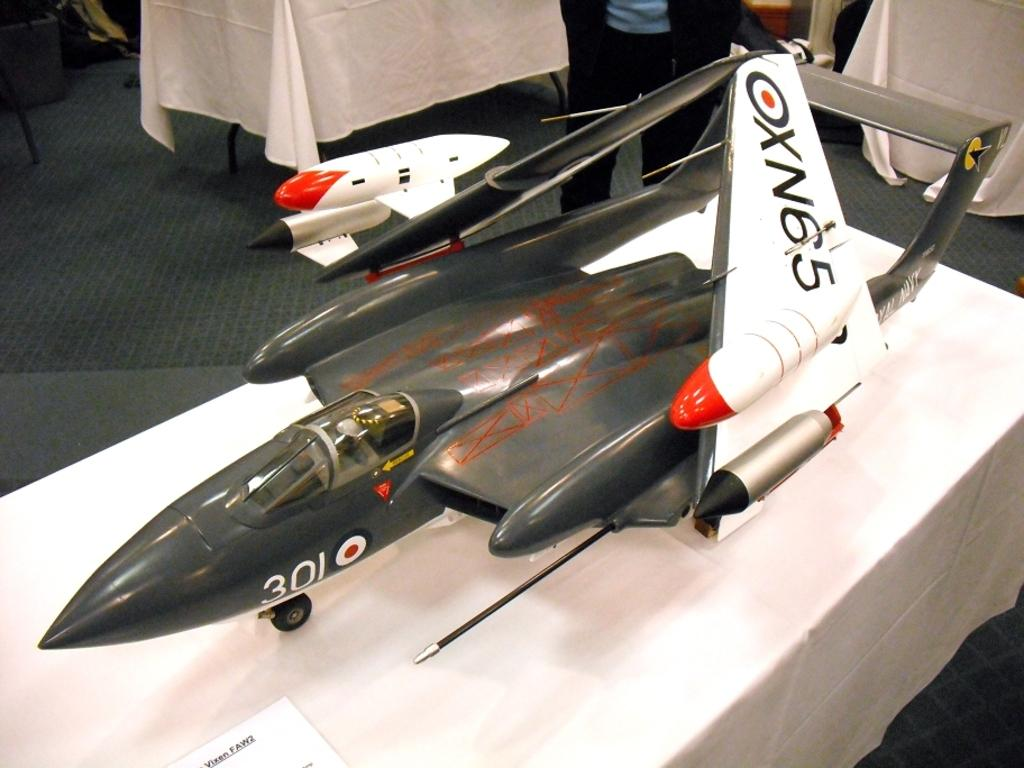<image>
Present a compact description of the photo's key features. A model of a millatary jet (number 301) with upturned wings on which is written: XN65. 